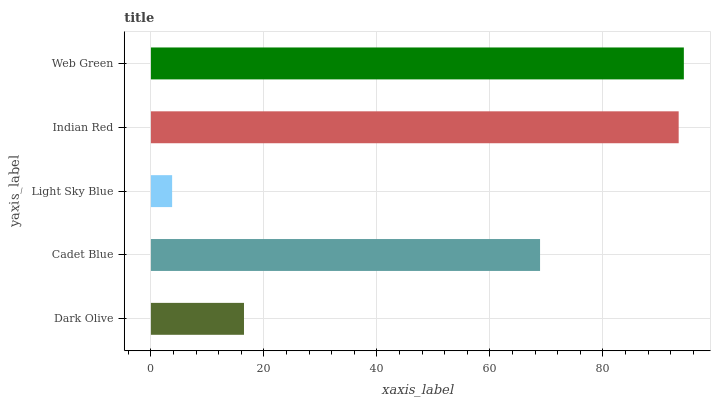Is Light Sky Blue the minimum?
Answer yes or no. Yes. Is Web Green the maximum?
Answer yes or no. Yes. Is Cadet Blue the minimum?
Answer yes or no. No. Is Cadet Blue the maximum?
Answer yes or no. No. Is Cadet Blue greater than Dark Olive?
Answer yes or no. Yes. Is Dark Olive less than Cadet Blue?
Answer yes or no. Yes. Is Dark Olive greater than Cadet Blue?
Answer yes or no. No. Is Cadet Blue less than Dark Olive?
Answer yes or no. No. Is Cadet Blue the high median?
Answer yes or no. Yes. Is Cadet Blue the low median?
Answer yes or no. Yes. Is Light Sky Blue the high median?
Answer yes or no. No. Is Light Sky Blue the low median?
Answer yes or no. No. 